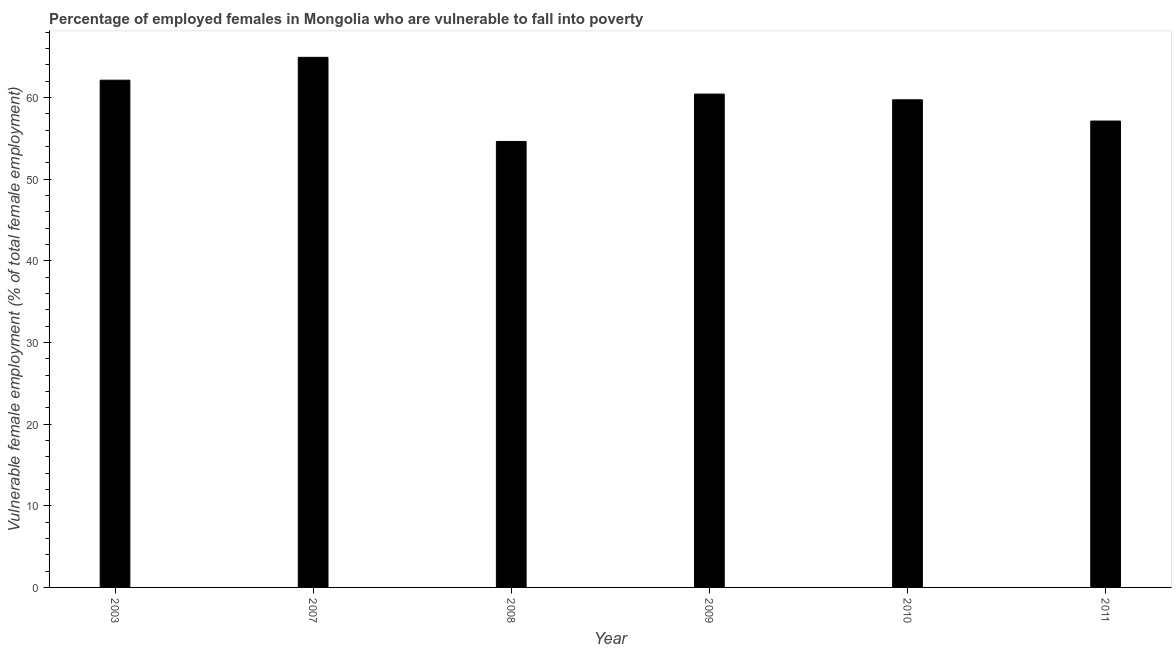What is the title of the graph?
Your answer should be very brief. Percentage of employed females in Mongolia who are vulnerable to fall into poverty. What is the label or title of the X-axis?
Provide a short and direct response. Year. What is the label or title of the Y-axis?
Your answer should be compact. Vulnerable female employment (% of total female employment). What is the percentage of employed females who are vulnerable to fall into poverty in 2008?
Provide a succinct answer. 54.6. Across all years, what is the maximum percentage of employed females who are vulnerable to fall into poverty?
Your answer should be very brief. 64.9. Across all years, what is the minimum percentage of employed females who are vulnerable to fall into poverty?
Give a very brief answer. 54.6. In which year was the percentage of employed females who are vulnerable to fall into poverty minimum?
Make the answer very short. 2008. What is the sum of the percentage of employed females who are vulnerable to fall into poverty?
Keep it short and to the point. 358.8. What is the average percentage of employed females who are vulnerable to fall into poverty per year?
Provide a succinct answer. 59.8. What is the median percentage of employed females who are vulnerable to fall into poverty?
Offer a very short reply. 60.05. What is the ratio of the percentage of employed females who are vulnerable to fall into poverty in 2003 to that in 2008?
Keep it short and to the point. 1.14. What is the difference between the highest and the second highest percentage of employed females who are vulnerable to fall into poverty?
Your response must be concise. 2.8. What is the difference between the highest and the lowest percentage of employed females who are vulnerable to fall into poverty?
Your answer should be compact. 10.3. In how many years, is the percentage of employed females who are vulnerable to fall into poverty greater than the average percentage of employed females who are vulnerable to fall into poverty taken over all years?
Offer a very short reply. 3. How many bars are there?
Provide a succinct answer. 6. Are all the bars in the graph horizontal?
Provide a short and direct response. No. What is the difference between two consecutive major ticks on the Y-axis?
Your response must be concise. 10. What is the Vulnerable female employment (% of total female employment) in 2003?
Your answer should be compact. 62.1. What is the Vulnerable female employment (% of total female employment) in 2007?
Offer a very short reply. 64.9. What is the Vulnerable female employment (% of total female employment) of 2008?
Your answer should be very brief. 54.6. What is the Vulnerable female employment (% of total female employment) of 2009?
Provide a short and direct response. 60.4. What is the Vulnerable female employment (% of total female employment) of 2010?
Your answer should be very brief. 59.7. What is the Vulnerable female employment (% of total female employment) in 2011?
Ensure brevity in your answer.  57.1. What is the difference between the Vulnerable female employment (% of total female employment) in 2003 and 2009?
Your answer should be very brief. 1.7. What is the difference between the Vulnerable female employment (% of total female employment) in 2007 and 2008?
Offer a very short reply. 10.3. What is the difference between the Vulnerable female employment (% of total female employment) in 2008 and 2009?
Your answer should be compact. -5.8. What is the difference between the Vulnerable female employment (% of total female employment) in 2008 and 2011?
Keep it short and to the point. -2.5. What is the difference between the Vulnerable female employment (% of total female employment) in 2009 and 2010?
Your answer should be compact. 0.7. What is the difference between the Vulnerable female employment (% of total female employment) in 2009 and 2011?
Provide a succinct answer. 3.3. What is the difference between the Vulnerable female employment (% of total female employment) in 2010 and 2011?
Your response must be concise. 2.6. What is the ratio of the Vulnerable female employment (% of total female employment) in 2003 to that in 2008?
Give a very brief answer. 1.14. What is the ratio of the Vulnerable female employment (% of total female employment) in 2003 to that in 2009?
Your response must be concise. 1.03. What is the ratio of the Vulnerable female employment (% of total female employment) in 2003 to that in 2011?
Give a very brief answer. 1.09. What is the ratio of the Vulnerable female employment (% of total female employment) in 2007 to that in 2008?
Offer a terse response. 1.19. What is the ratio of the Vulnerable female employment (% of total female employment) in 2007 to that in 2009?
Your answer should be very brief. 1.07. What is the ratio of the Vulnerable female employment (% of total female employment) in 2007 to that in 2010?
Make the answer very short. 1.09. What is the ratio of the Vulnerable female employment (% of total female employment) in 2007 to that in 2011?
Provide a short and direct response. 1.14. What is the ratio of the Vulnerable female employment (% of total female employment) in 2008 to that in 2009?
Your answer should be very brief. 0.9. What is the ratio of the Vulnerable female employment (% of total female employment) in 2008 to that in 2010?
Your answer should be very brief. 0.92. What is the ratio of the Vulnerable female employment (% of total female employment) in 2008 to that in 2011?
Ensure brevity in your answer.  0.96. What is the ratio of the Vulnerable female employment (% of total female employment) in 2009 to that in 2011?
Make the answer very short. 1.06. What is the ratio of the Vulnerable female employment (% of total female employment) in 2010 to that in 2011?
Offer a very short reply. 1.05. 